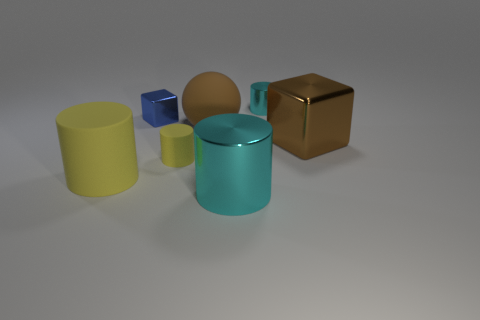How many tiny things are either brown rubber balls or gray rubber balls?
Your response must be concise. 0. There is a big cyan metallic thing; are there any small metal things to the right of it?
Keep it short and to the point. Yes. Is the number of big matte objects that are in front of the big metallic cylinder the same as the number of blue things?
Your response must be concise. No. What size is the other metal object that is the same shape as the large cyan shiny thing?
Offer a very short reply. Small. Does the tiny cyan object have the same shape as the big thing that is behind the large brown shiny block?
Your response must be concise. No. There is a yellow matte thing left of the tiny shiny thing that is left of the small metal cylinder; how big is it?
Provide a short and direct response. Large. Are there the same number of large brown matte objects that are to the left of the blue thing and big rubber balls that are on the right side of the brown matte thing?
Offer a very short reply. Yes. There is another thing that is the same shape as the tiny blue metallic thing; what is its color?
Make the answer very short. Brown. How many rubber objects have the same color as the sphere?
Make the answer very short. 0. There is a yellow matte object to the right of the tiny blue metallic object; does it have the same shape as the big yellow rubber object?
Keep it short and to the point. Yes. 